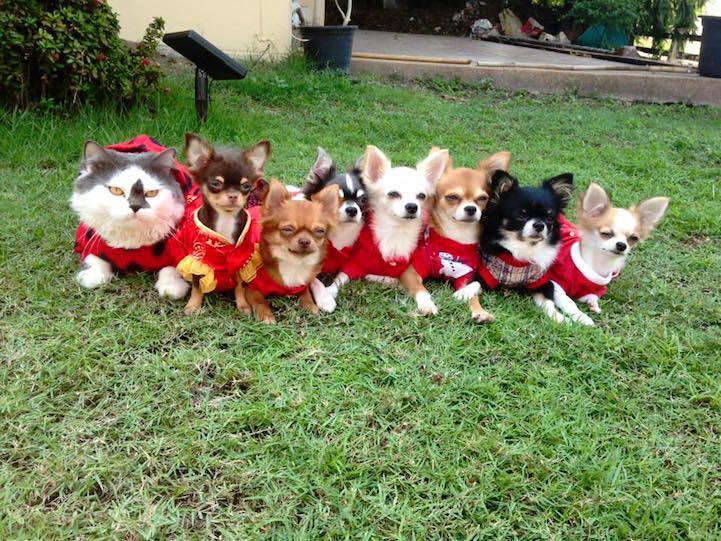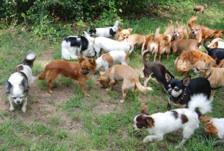The first image is the image on the left, the second image is the image on the right. Analyze the images presented: Is the assertion "there is a row of animals dressed in clothes" valid? Answer yes or no. Yes. The first image is the image on the left, the second image is the image on the right. For the images displayed, is the sentence "One image contains exactly three dogs." factually correct? Answer yes or no. No. 